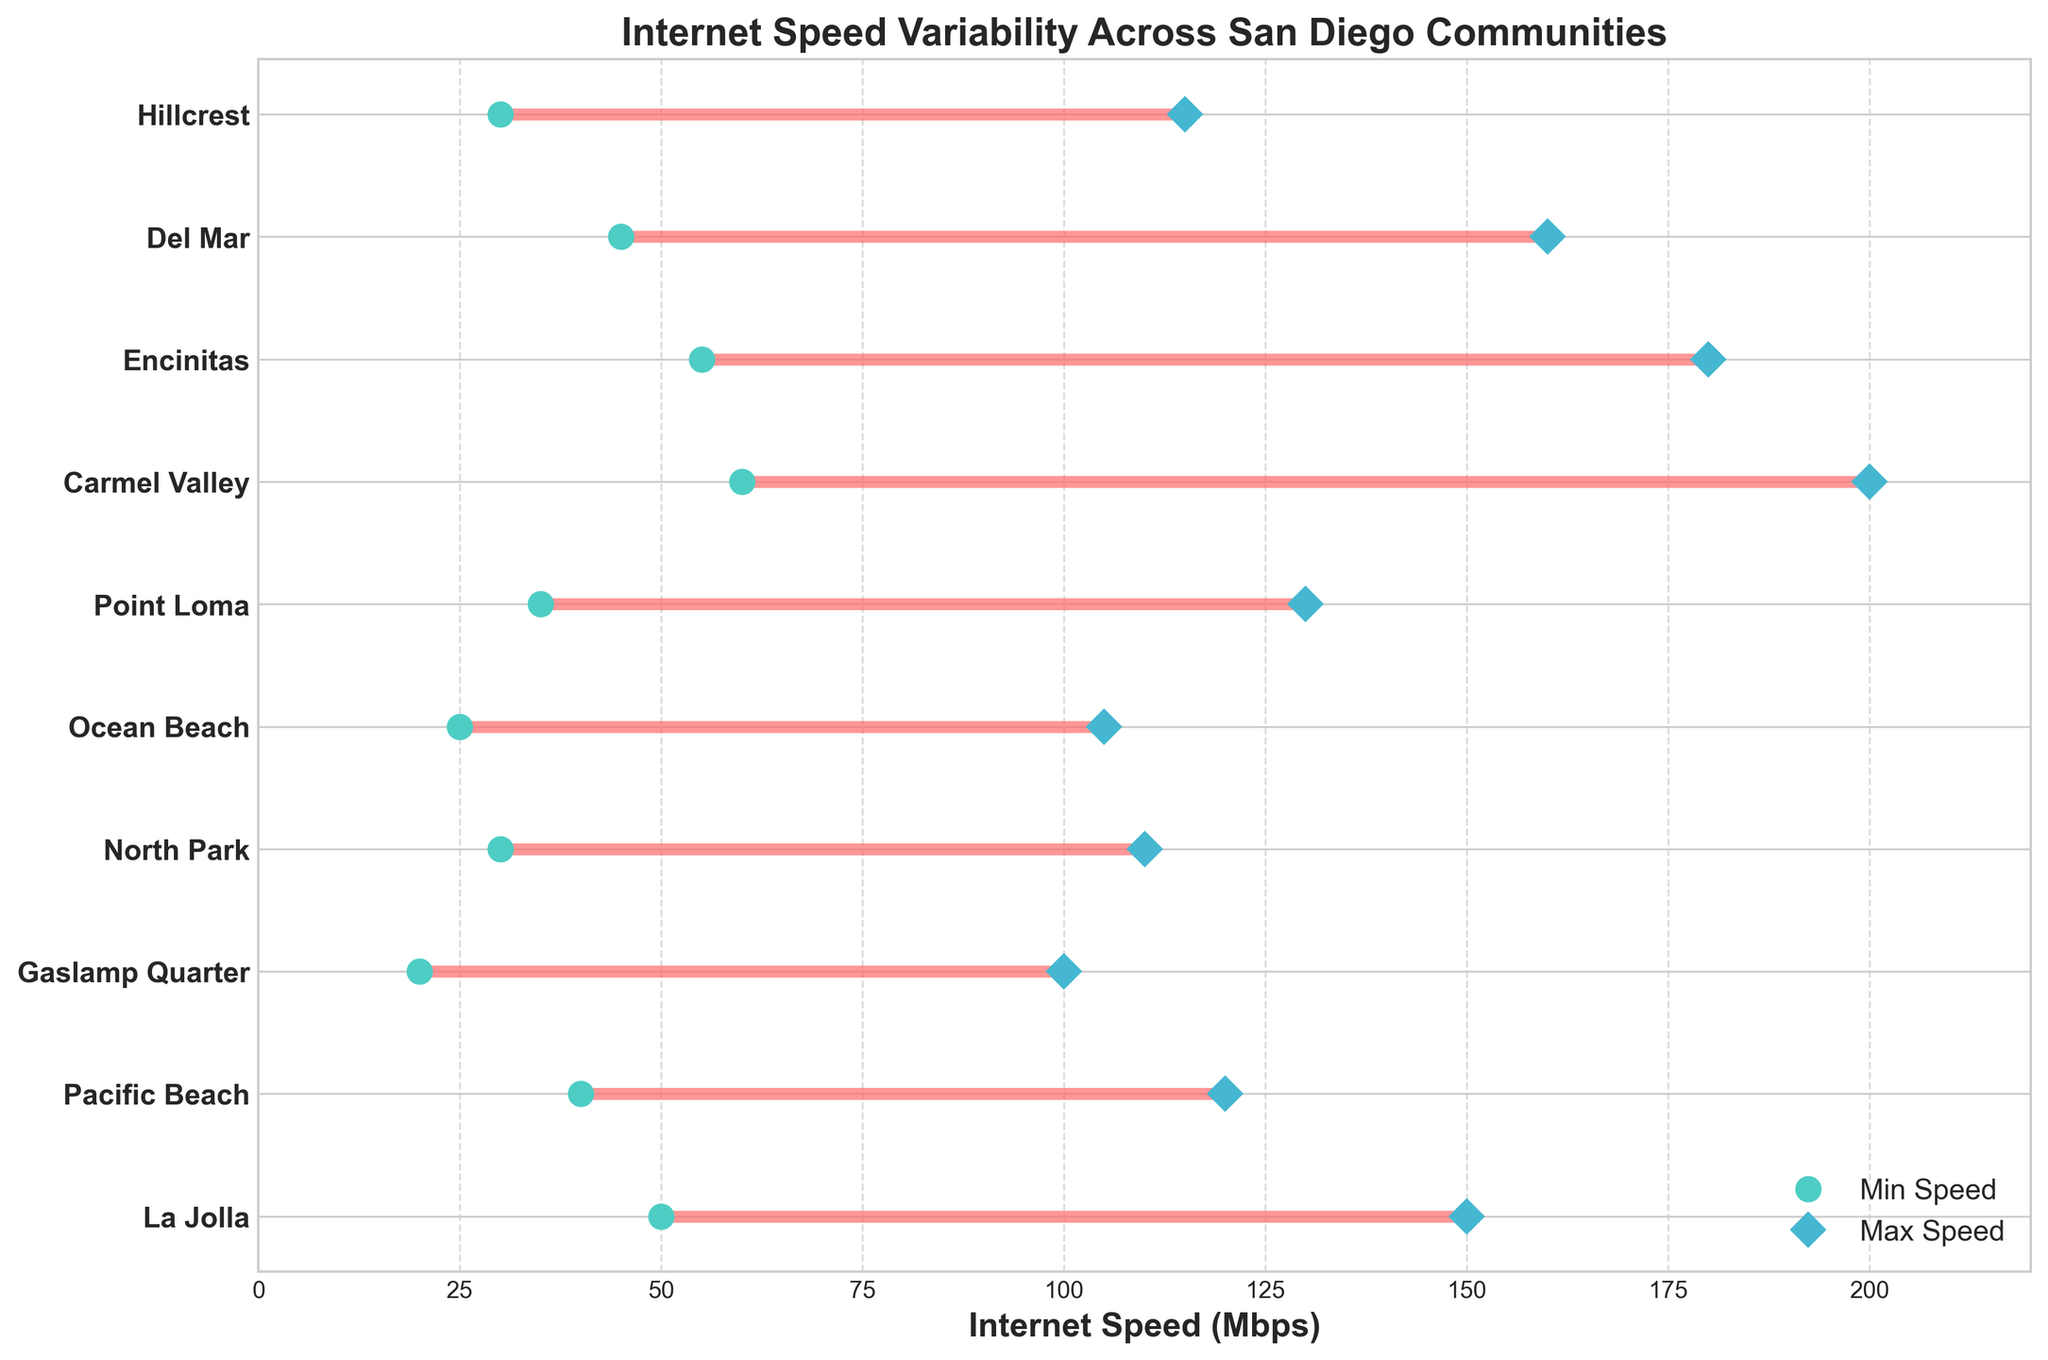What is the title of the figure? The title of the figure is typically located at the top of the chart. A quick glance at the top reveals the exact title used in this plot.
Answer: Internet Speed Variability Across San Diego Communities What is the maximum internet speed in Carmel Valley? The figure plots both minimum and maximum internet speeds for each community. By looking at the ranging dot associated with Carmel Valley, the maximum value marked with a diamond shape is clearly indicated.
Answer: 200 Mbps Which community has the lowest minimum internet speed? To identify the lowest minimum internet speed, inspect the left-end points of each line segment (dots). The community with the lowest dot position on the x-axis represents this value. In this case, it's associated with the Gaslamp Quarter.
Answer: Gaslamp Quarter Which community has the highest maximum internet speed? To find the community with the highest maximum speed, compare the farthest right-end points of the line segments (diamonds). The one reaching the furthest right represents this value, which is Carmel Valley.
Answer: Carmel Valley What is the range of internet speeds in Encinitas? The range of internet speeds is computed by subtracting the minimum speed from the maximum speed for Encinitas. According to the plot, these values are 55 Mbps and 180 Mbps respectively. So, 180 - 55 = 125.
Answer: 125 Mbps Does Ocean Beach have a higher maximum internet speed than Gaslamp Quarter? Compare the maximum speed values (diamond shapes) for both Ocean Beach and Gaslamp Quarter. Ocean Beach's maximum speed reaches 105 Mbps while Gaslamp Quarter's maximum speed is 100 Mbps. Hence, Ocean Beach does have a higher maximum speed.
Answer: Yes Which community has a more extensive range of internet speeds: Pacific Beach or Hillcrest? Calculate the range for each by subtracting the minimum speed from the maximum speed: Pacific Beach (120 - 40 = 80) and Hillcrest (115 - 30 = 85). Compare these values to determine that Hillcrest has a more extensive range.
Answer: Hillcrest What is the median of the maximum speeds across all communities? List all maximum speeds (150, 120, 100, 110, 105, 130, 200, 180, 160, 115) and arrange them in ascending order (100, 105, 110, 115, 120, 130, 150, 160, 180, 200). The median is the average of the 5th and 6th values: (120 + 130)/2 = 125.
Answer: 125 Mbps Which community has a closer range of minimum and maximum speeds: La Jolla or Del Mar? Compute the range for each: La Jolla (150 - 50 = 100) and Del Mar (160 - 45 = 115). Compare these values to deduce that La Jolla has a closer range.
Answer: La Jolla 